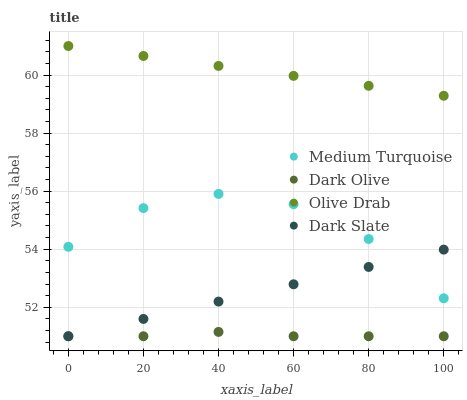Does Dark Olive have the minimum area under the curve?
Answer yes or no. Yes. Does Olive Drab have the maximum area under the curve?
Answer yes or no. Yes. Does Olive Drab have the minimum area under the curve?
Answer yes or no. No. Does Dark Olive have the maximum area under the curve?
Answer yes or no. No. Is Dark Slate the smoothest?
Answer yes or no. Yes. Is Medium Turquoise the roughest?
Answer yes or no. Yes. Is Dark Olive the smoothest?
Answer yes or no. No. Is Dark Olive the roughest?
Answer yes or no. No. Does Dark Slate have the lowest value?
Answer yes or no. Yes. Does Olive Drab have the lowest value?
Answer yes or no. No. Does Olive Drab have the highest value?
Answer yes or no. Yes. Does Dark Olive have the highest value?
Answer yes or no. No. Is Dark Olive less than Olive Drab?
Answer yes or no. Yes. Is Olive Drab greater than Medium Turquoise?
Answer yes or no. Yes. Does Dark Slate intersect Medium Turquoise?
Answer yes or no. Yes. Is Dark Slate less than Medium Turquoise?
Answer yes or no. No. Is Dark Slate greater than Medium Turquoise?
Answer yes or no. No. Does Dark Olive intersect Olive Drab?
Answer yes or no. No. 